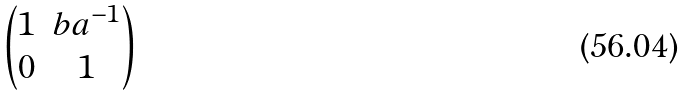Convert formula to latex. <formula><loc_0><loc_0><loc_500><loc_500>\begin{pmatrix} 1 & b a ^ { - 1 } \\ 0 & 1 \end{pmatrix}</formula> 